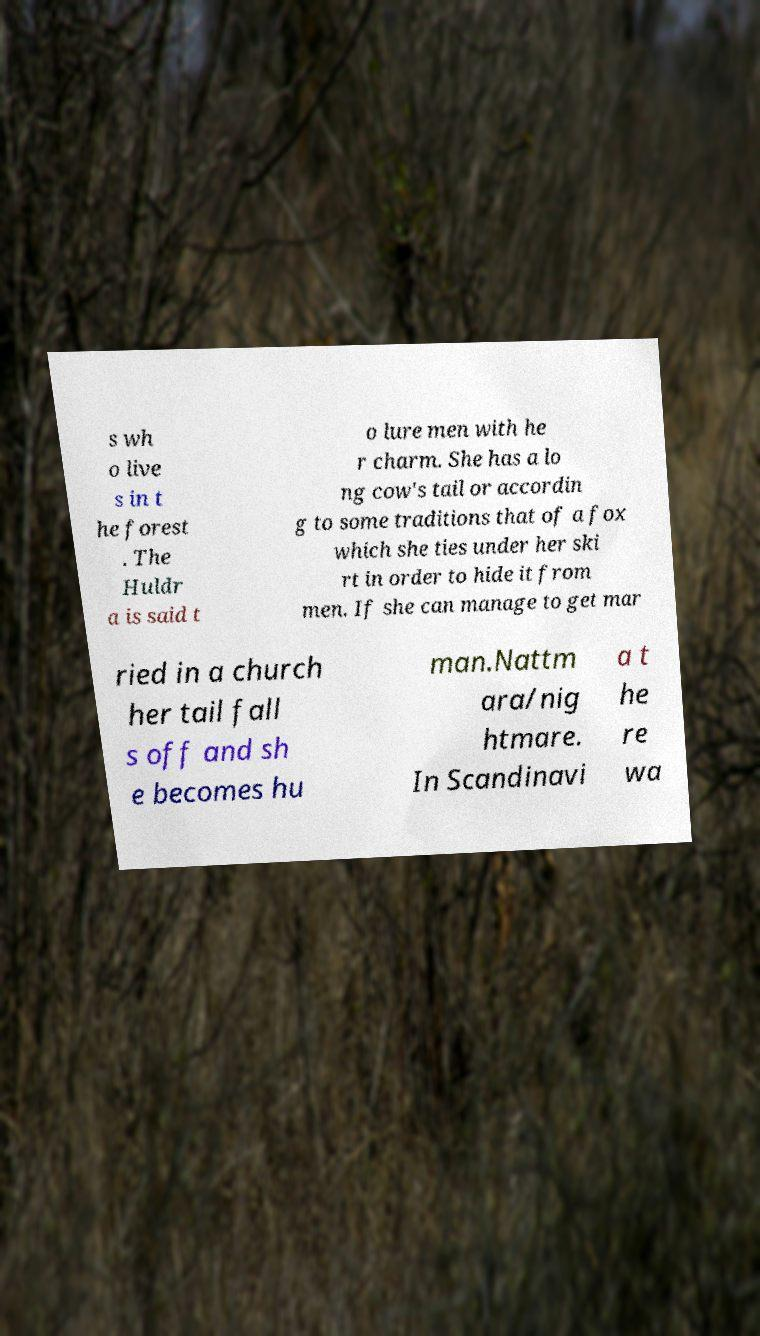Could you assist in decoding the text presented in this image and type it out clearly? s wh o live s in t he forest . The Huldr a is said t o lure men with he r charm. She has a lo ng cow's tail or accordin g to some traditions that of a fox which she ties under her ski rt in order to hide it from men. If she can manage to get mar ried in a church her tail fall s off and sh e becomes hu man.Nattm ara/nig htmare. In Scandinavi a t he re wa 